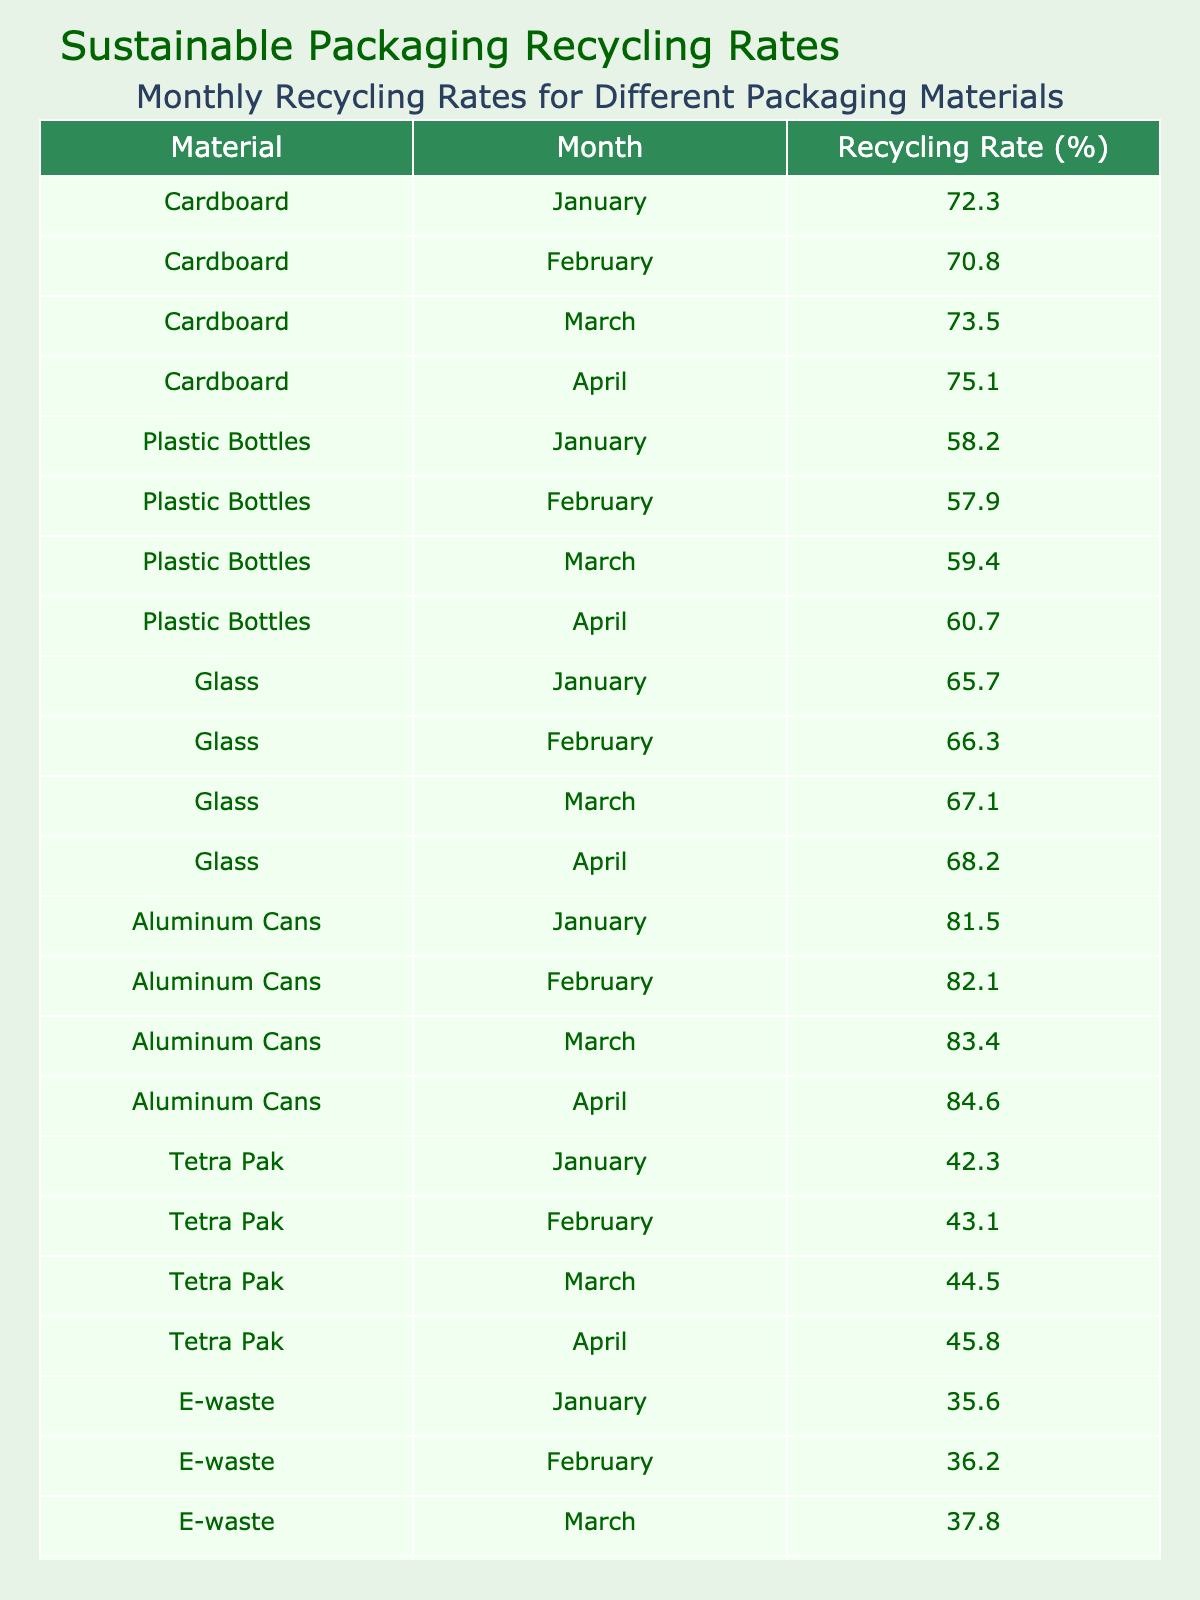What was the recycling rate for cardboard in March? The table lists the recycling rates for cardboard, and in March, it shows a recycling rate of 73.5%.
Answer: 73.5% Which material had the lowest recycling rate in January? The recycling rates in January are as follows: Cardboard (72.3%), Plastic Bottles (58.2%), Glass (65.7%), Aluminum Cans (81.5%), Tetra Pak (42.3%), E-waste (35.6%), Compostable Packaging (51.4%), Paper (68.9%). The lowest recycling rate is for E-waste at 35.6%.
Answer: E-waste What is the average recycling rate for glass over the four months? For glass, the recycling rates are: January (65.7%), February (66.3%), March (67.1%), April (68.2%). The sum of these rates is 267.3%. Dividing by 4 gives an average of 66.825%.
Answer: 66.8% Did the recycling rate for plastic bottles increase from January to April? The table shows the rates for plastic bottles: January (58.2%), February (57.9%), March (59.4%), April (60.7%). The recycling rates increased from January to April.
Answer: Yes What was the total recycling rate for aluminum cans during the first quarter (January to March)? The recycling rates for aluminum cans from January (81.5%), February (82.1%), March (83.4%) are summed: 81.5 + 82.1 + 83.4 = 247. The total recycling rate for the first quarter is 247%.
Answer: 247% Which material had the highest recycling rate in April? In April, the recycling rates are: Cardboard (75.1%), Plastic Bottles (60.7%), Glass (68.2%), Aluminum Cans (84.6%), Tetra Pak (45.8%), E-waste (39.1%), Compostable Packaging (55.9%), Paper (71.6%). The highest rate is for Aluminum Cans at 84.6%.
Answer: Aluminum Cans What is the difference in recycling rates for Tetra Pak from January to April? The recycling rate for Tetra Pak in January is 42.3% and in April is 45.8%. The difference is calculated as 45.8% - 42.3% = 3.5%.
Answer: 3.5% What percentage of the recycling rate in February for compostable packaging is greater than the rate for e-waste? The recycling rates are: Compostable Packaging (February) 52.7% and E-waste (February) 36.2%. To find the difference: 52.7% - 36.2% = 16.5%. Therefore, compostable packaging is 16.5% greater than e-waste.
Answer: 16.5% In which month did paper recycling rate first exceed 70%? The table shows the recycling rates for paper: January (68.9%), February (69.5%), March (70.8%), April (71.6%). Paper first exceeded 70% in March.
Answer: March What was the average recycling rate for compostable packaging over the four months? The rates for compostable packaging are: January (51.4%), February (52.7%), March (54.2%), April (55.9%). Adding these gives: 214.2%. Dividing by 4 yields an average of 53.55%.
Answer: 53.6% 